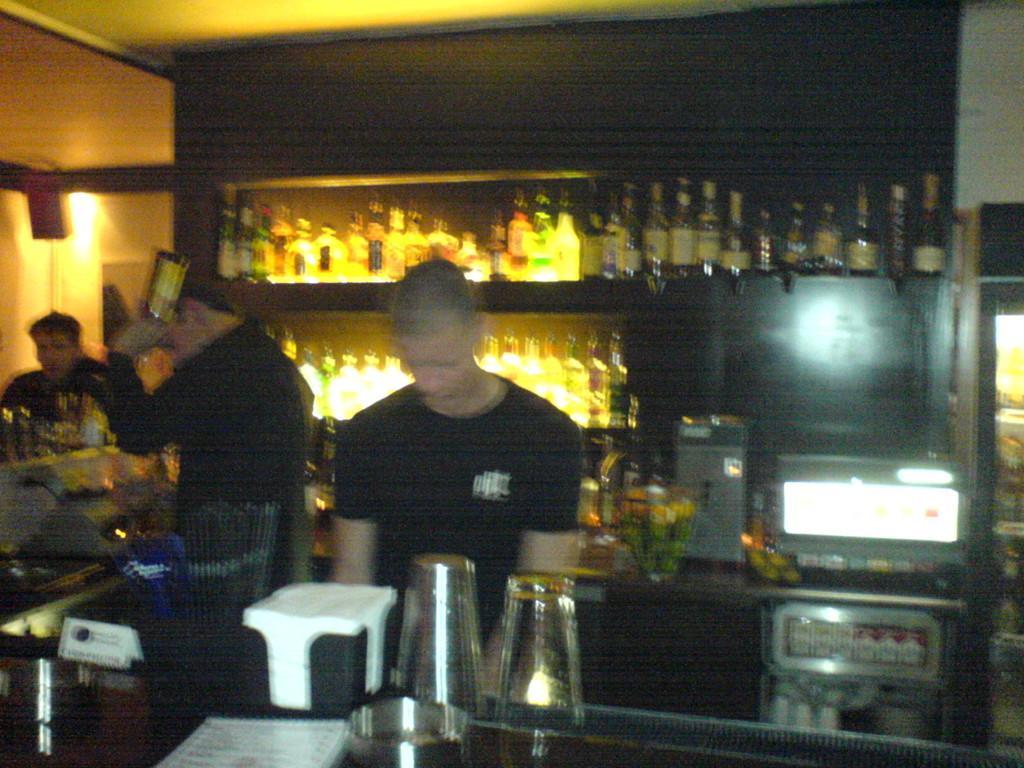Describe this image in one or two sentences. In this image we can see two persons and among them a person is holding a bottle. In front of the persons there are few objects on the table. Behind the persons we can see a wall and bottles with lights on the shelves. On the right side, we can see few objects on the table. On the left side, we can see a person, wall and a light. At the top we can see the roof. 